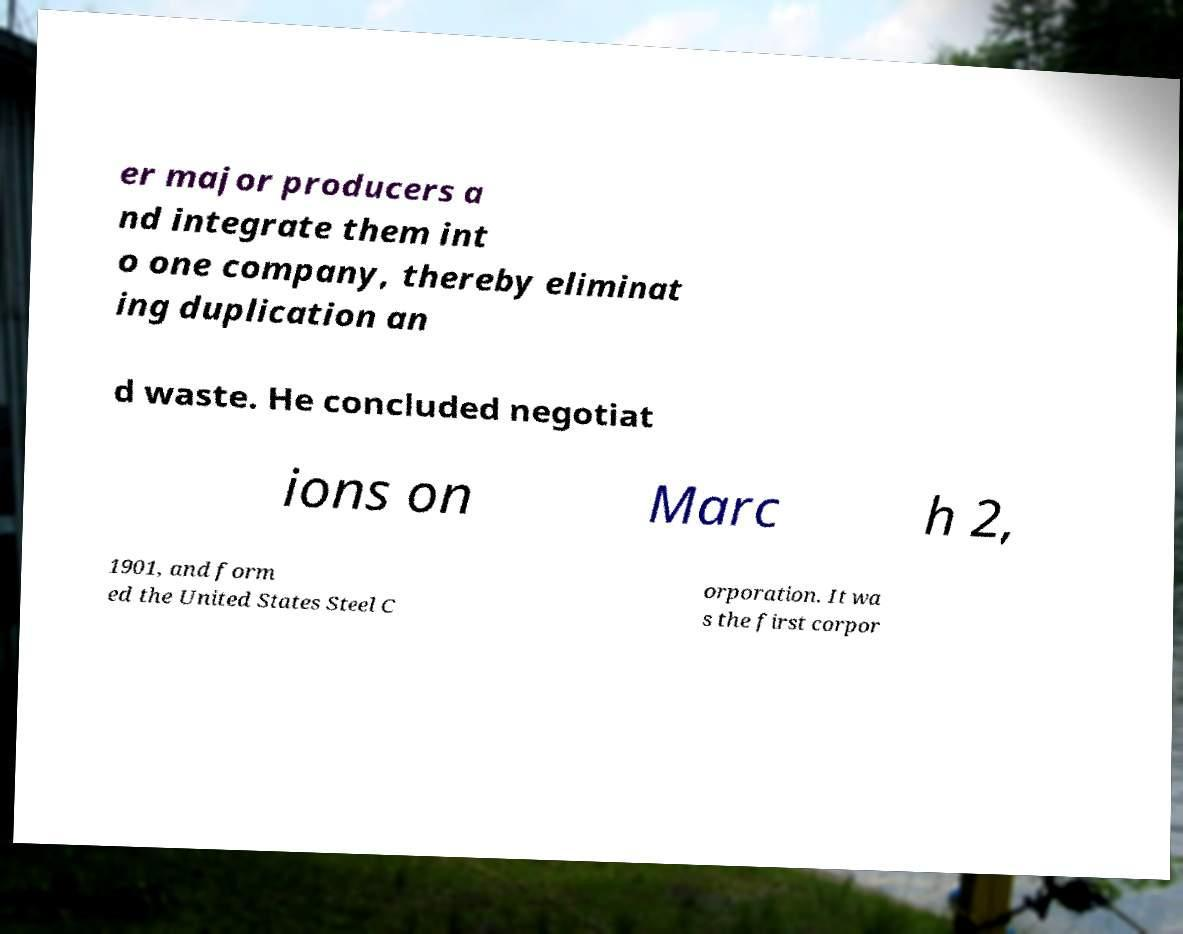Could you extract and type out the text from this image? er major producers a nd integrate them int o one company, thereby eliminat ing duplication an d waste. He concluded negotiat ions on Marc h 2, 1901, and form ed the United States Steel C orporation. It wa s the first corpor 